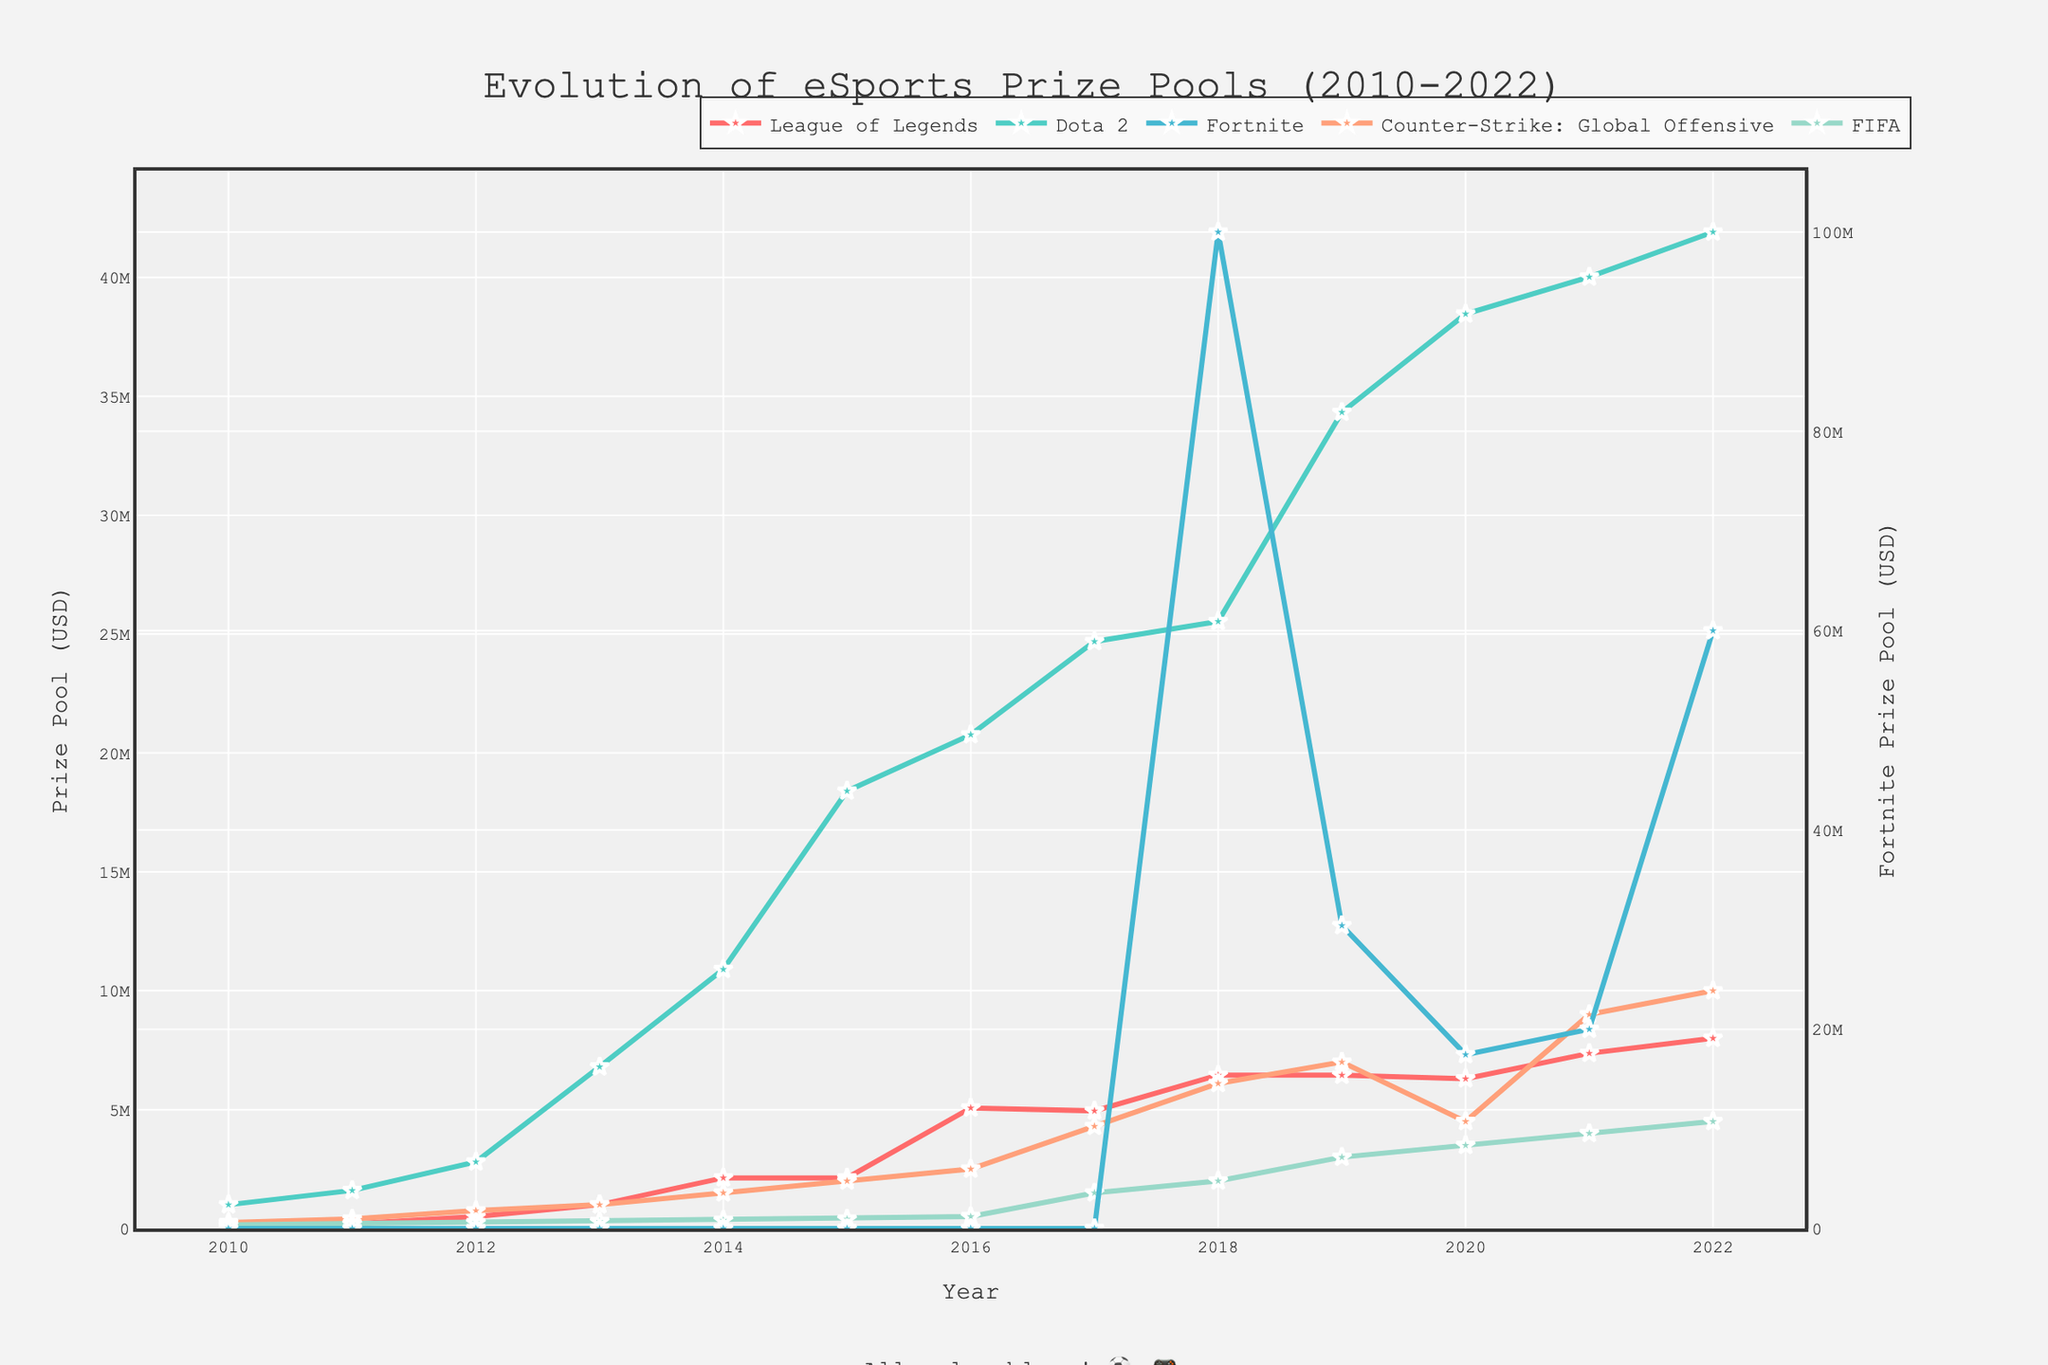Which game had the highest prize pool in 2022 and what was its value? Look at the data points for 2022 and compare the prize pool values for all games. The highest value is for the game Fortnite.
Answer: Fortnite, 60000000 In which year did Fortnite first appear in the prize pool ranking? By observing the line for Fortnite, we can see it first appears in 2018 with a notable prize pool.
Answer: 2018 By how much did the Fortnite prize pool increase from 2018 to 2019? Note the prize pool values for Fortnite in 2018 and 2019. The increase is calculated as 30400000 - 100000000.
Answer: -69600000 Which game had a decreasing trend in prize pool values from 2019 to 2020? Look at the lines for each game between 2019 and 2020 and identify which ones show a downward trend. Dota 2 and Fortnite both fit this description.
Answer: Dota 2, Fortnite What was the average prize pool value for Counter-Strike: Global Offensive from 2010 to 2022? Sum the prize pool values for Counter-Strike: Global Offensive from 2010 to 2022 and divide by the number of years (13). The calculation is (250000 + 400000 + 750000 + 1000000 + 1500000 + 2000000 + 2500000 + 4300000 + 6100000 + 7000000 + 4500000 + 9000000 + 10000000) / 13.
Answer: 4576923.08 Between 2010 and 2022, which game consistently increased its prize pool every year? Observe the prize pool line trends for each game over the years. Only FIFA shows a steady increase without any decrease.
Answer: FIFA Compare the prize pool value of Dota 2 in 2013 with League of Legends in 2016. Which one was higher and by how much? Identify the prize pool values for Dota 2 in 2013 (6800000) and League of Legends in 2016 (5070000). Subtract the smaller value from the larger one: 6800000 - 5070000.
Answer: Dota 2, 1730000 In which year did League of Legends have the highest prize pool, and what was the value? Observe the data points for League of Legends across all years. The highest value is in 2022.
Answer: 2022, 8000000 Among all the games in 2021, which game had the third-highest prize pool? Sort the prize pool values for each game in 2021 in descending order. The third-highest value belongs to League of Legends.
Answer: League of Legends 